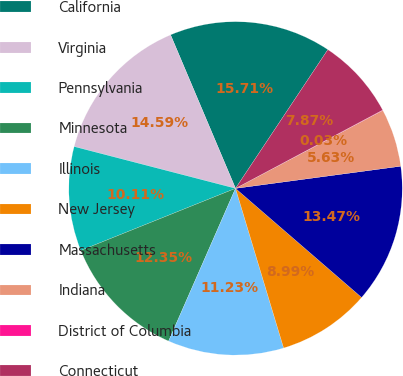<chart> <loc_0><loc_0><loc_500><loc_500><pie_chart><fcel>California<fcel>Virginia<fcel>Pennsylvania<fcel>Minnesota<fcel>Illinois<fcel>New Jersey<fcel>Massachusetts<fcel>Indiana<fcel>District of Columbia<fcel>Connecticut<nl><fcel>15.71%<fcel>14.59%<fcel>10.11%<fcel>12.35%<fcel>11.23%<fcel>8.99%<fcel>13.47%<fcel>5.63%<fcel>0.03%<fcel>7.87%<nl></chart> 